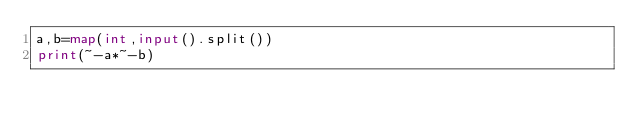<code> <loc_0><loc_0><loc_500><loc_500><_Python_>a,b=map(int,input().split())
print(~-a*~-b)</code> 